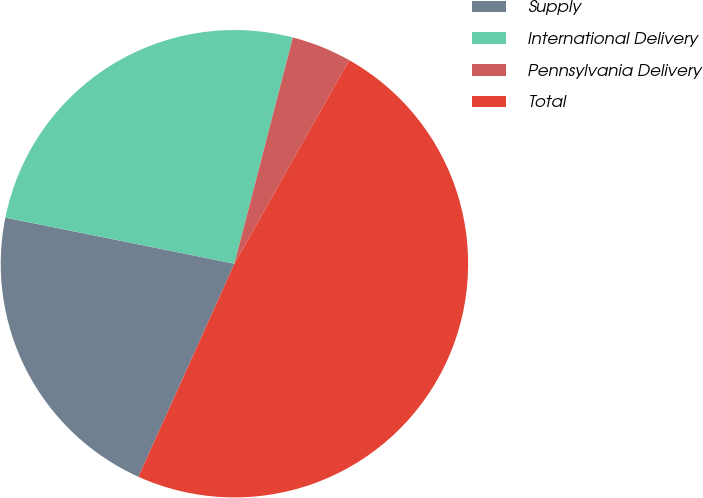<chart> <loc_0><loc_0><loc_500><loc_500><pie_chart><fcel>Supply<fcel>International Delivery<fcel>Pennsylvania Delivery<fcel>Total<nl><fcel>21.42%<fcel>25.86%<fcel>4.15%<fcel>48.57%<nl></chart> 